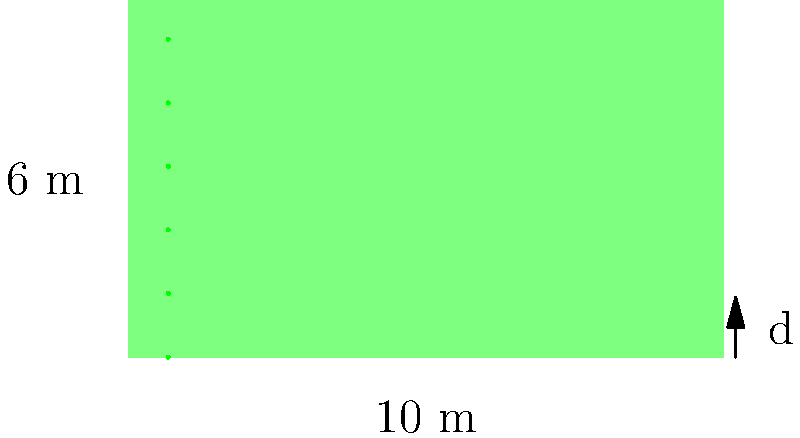A soybean farmer wants to optimize the spacing between rows in a rectangular field measuring 10 meters by 6 meters. If the farmer aims to have 6 equally spaced rows of soybeans, what should be the distance $d$ (in meters) between each row to maximize the use of the field? To find the optimal spacing between soybean rows, we'll follow these steps:

1) First, we need to understand that the 6 meters represents the width of the field, where the rows will be placed.

2) With 6 rows, there will be 5 spaces between the rows, plus two half-spaces at the edges of the field.

3) We can represent this mathematically as:
   $6 \text{ m} = 5d + d = 6d$

   Where $d$ is the distance between rows, and the extra $d$ comes from the two half-spaces ($\frac{1}{2}d + \frac{1}{2}d = d$).

4) Now we can solve for $d$:
   $6 \text{ m} = 6d$
   $d = 6 \text{ m} \div 6 = 1 \text{ m}$

5) Therefore, the optimal spacing between each row is 1 meter.

This spacing ensures that the rows are evenly distributed across the width of the field, maximizing the use of available space.
Answer: 1 m 